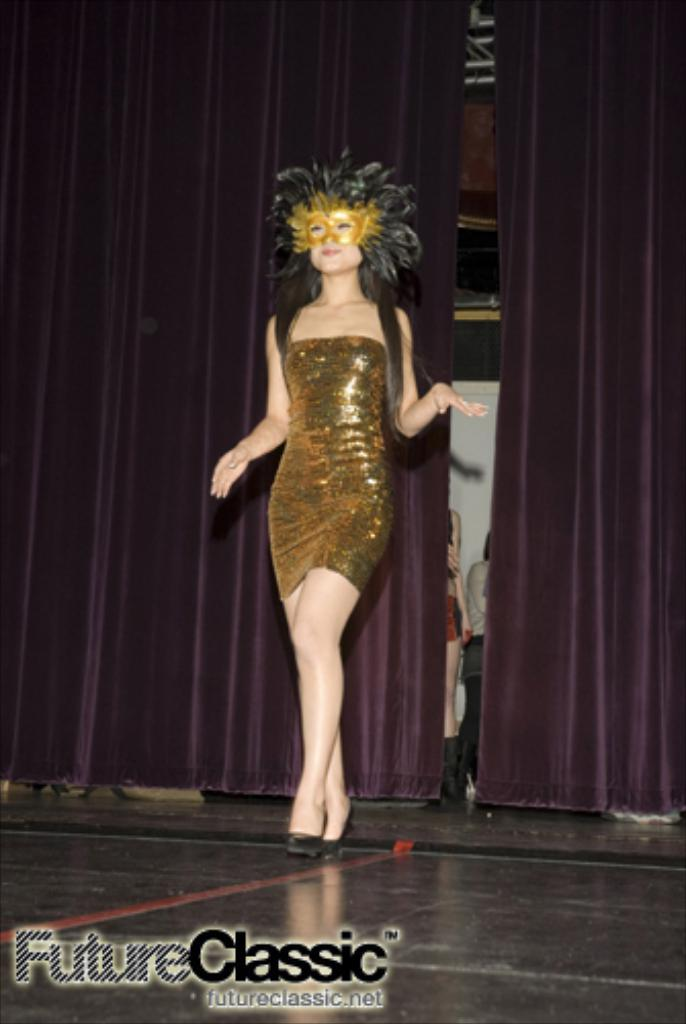Who or what can be seen in the image? There are people in the image. What can be found in the background or surrounding the people? There are curtains in the image. What else is present in the image besides the people and curtains? There are objects in the image. Is there any additional information or marking on the image? There is a watermark at the bottom of the image. Reasoning: Let's think step by step by step in order to produce the conversation. We start by identifying the main subjects in the image, which are the people. Then, we expand the conversation to include other elements that are also visible, such as the curtains, objects, and watermark. Each question is designed to elicit a specific detail about the image that is known from the provided facts. Absurd Question/Answer: How does the rainstorm affect the people in the image? There is no rainstorm present in the image; it only features people, curtains, objects, and a watermark. What type of comb is being used by the people in the image? There is no comb visible in the image. How does the rainstorm affect the people in the image? There is no rainstorm present in the image; it only features people, curtains, objects, and a watermark. What type of comb is being used by the people in the image? There is no comb visible in the image. 